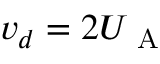Convert formula to latex. <formula><loc_0><loc_0><loc_500><loc_500>v _ { d } = 2 U _ { A }</formula> 